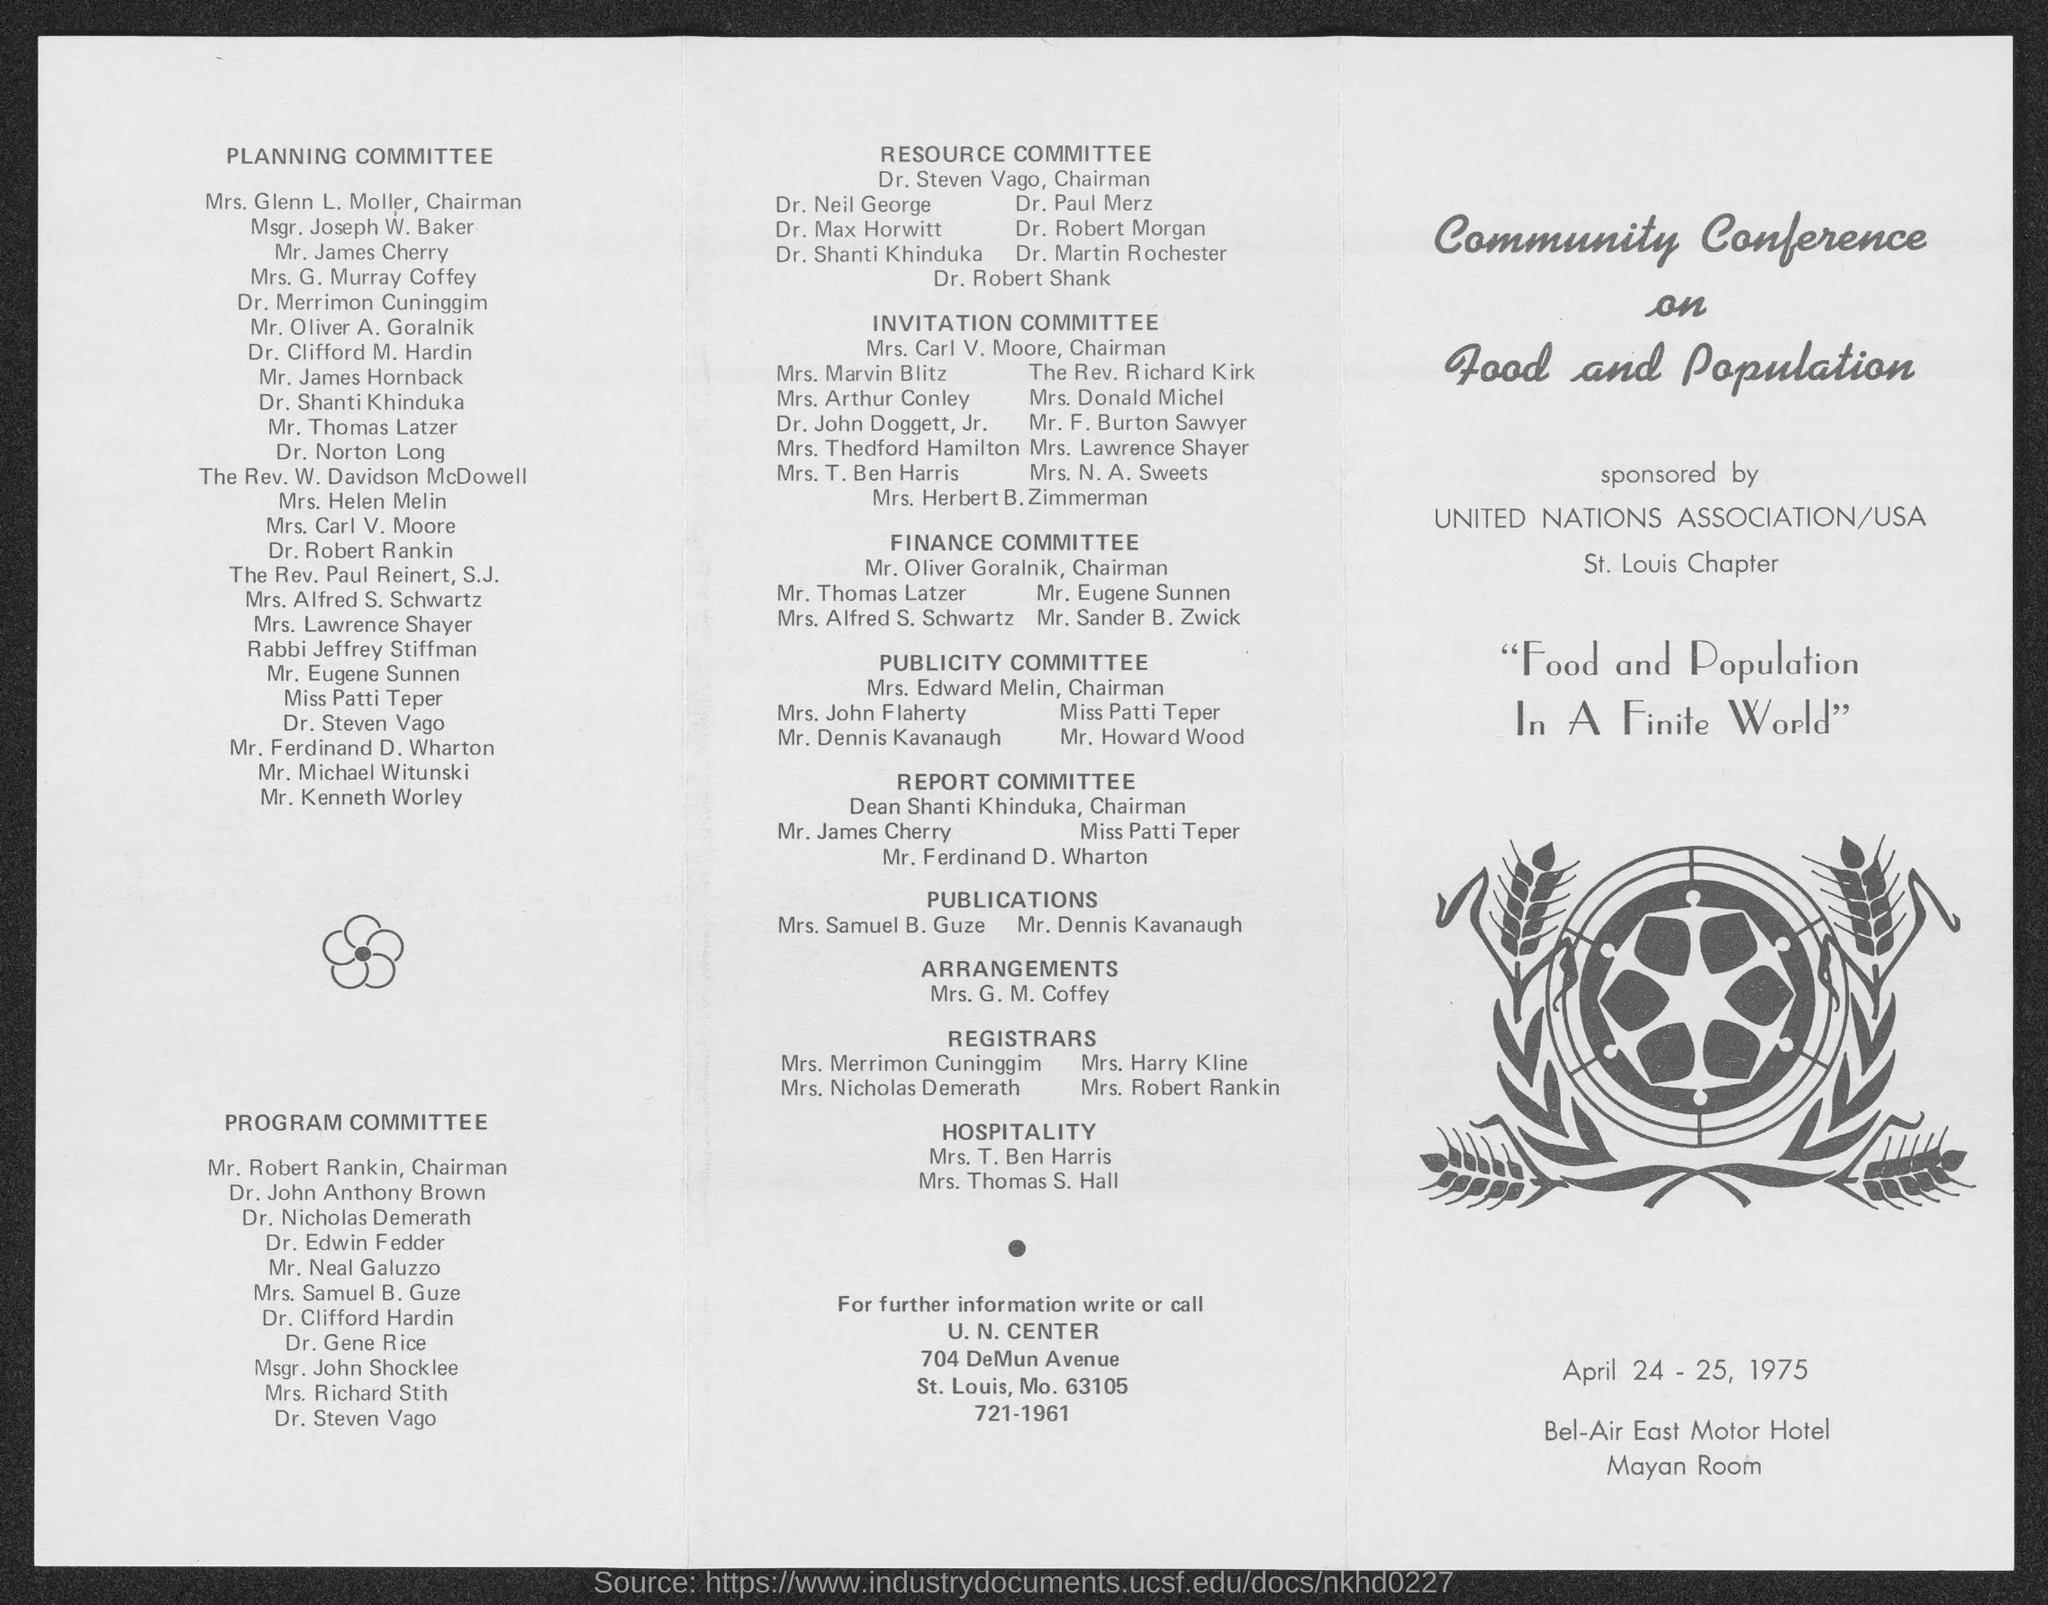Give some essential details in this illustration. Mr. Robert Rankin holds the designation of Chairman for the PROGRAM COMMITTEE. The Community Conference on Food and Population was held on April 24-25, 1975. The United Nations Association/USA St. Louis Chapter sponsors the Community Conference on Food and Population. The chairman of the Resource Committee is Dr. Steven Vago. The chairman of the Planning Committee is Mrs. Glenn L. Moller. 